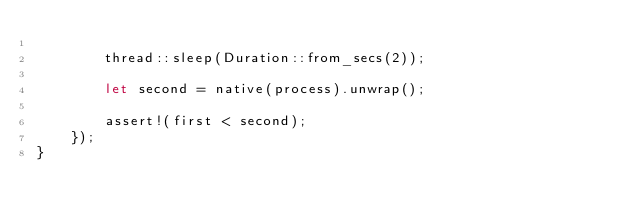Convert code to text. <code><loc_0><loc_0><loc_500><loc_500><_Rust_>
        thread::sleep(Duration::from_secs(2));

        let second = native(process).unwrap();

        assert!(first < second);
    });
}
</code> 